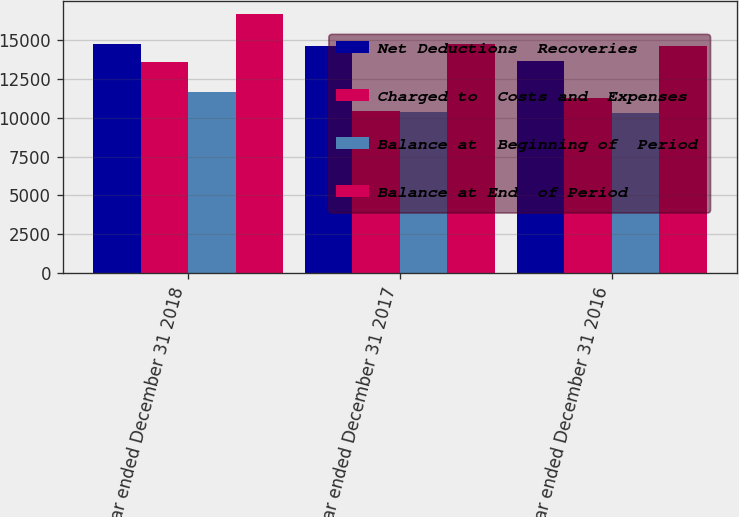<chart> <loc_0><loc_0><loc_500><loc_500><stacked_bar_chart><ecel><fcel>Year ended December 31 2018<fcel>Year ended December 31 2017<fcel>Year ended December 31 2016<nl><fcel>Net Deductions  Recoveries<fcel>14706<fcel>14600<fcel>13636<nl><fcel>Charged to  Costs and  Expenses<fcel>13606<fcel>10455<fcel>11257<nl><fcel>Balance at  Beginning of  Period<fcel>11646<fcel>10349<fcel>10293<nl><fcel>Balance at End  of Period<fcel>16666<fcel>14706<fcel>14600<nl></chart> 